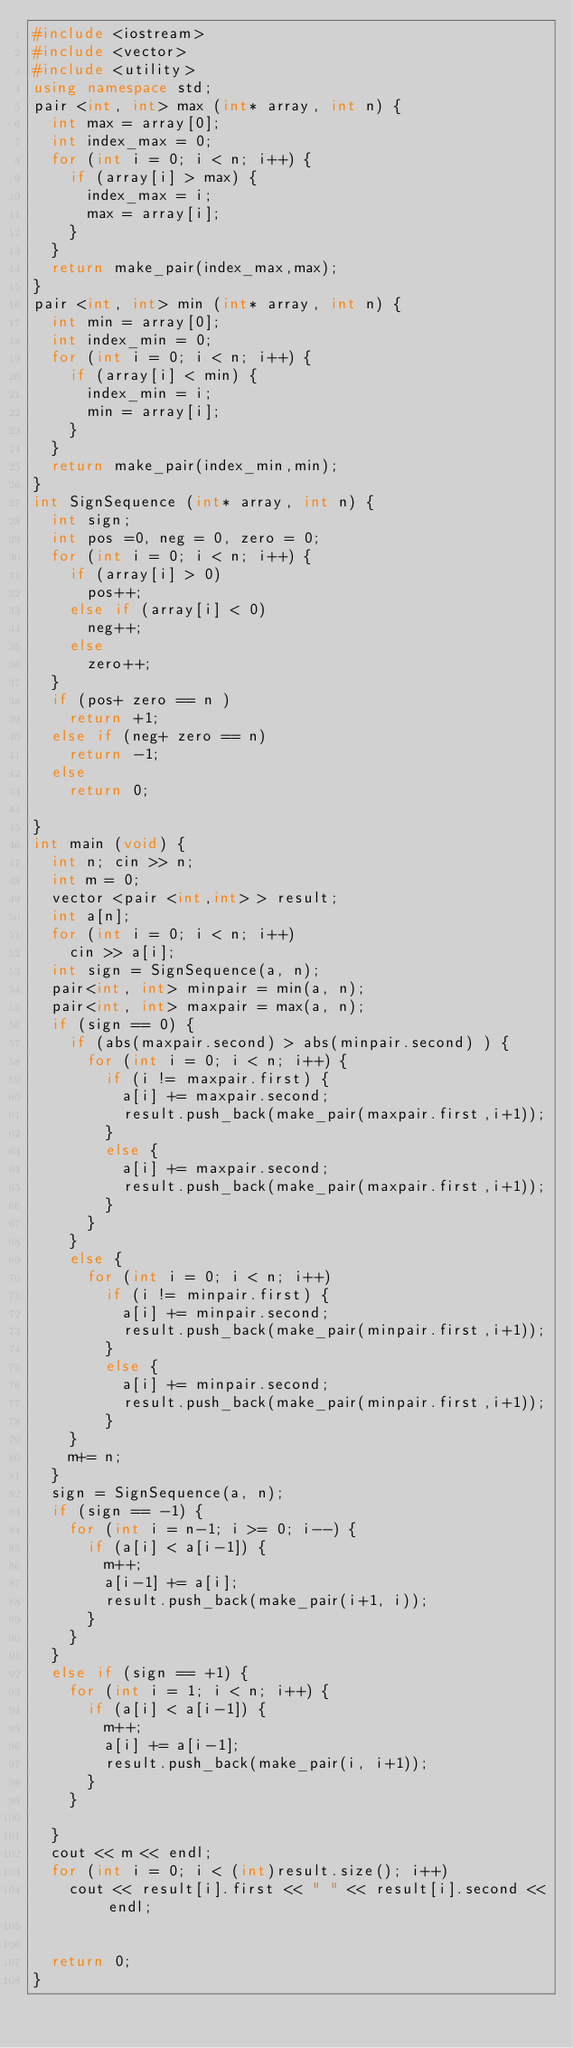Convert code to text. <code><loc_0><loc_0><loc_500><loc_500><_C++_>#include <iostream>
#include <vector>
#include <utility>
using namespace std;
pair <int, int> max (int* array, int n) {
	int max = array[0];
	int index_max = 0;
	for (int i = 0; i < n; i++) {
		if (array[i] > max) {
			index_max = i;
			max = array[i];
		}
	}
	return make_pair(index_max,max);
}
pair <int, int> min (int* array, int n) {
	int min = array[0];
	int index_min = 0;
	for (int i = 0; i < n; i++) {
		if (array[i] < min) {
			index_min = i;
			min = array[i];
		}
	}
	return make_pair(index_min,min);
}
int SignSequence (int* array, int n) {
	int sign;
	int pos =0, neg = 0, zero = 0;
	for (int i = 0; i < n; i++) {
		if (array[i] > 0)
			pos++;
		else if (array[i] < 0)
			neg++;
		else
			zero++;
	}
	if (pos+ zero == n )
		return +1;
	else if (neg+ zero == n)
		return -1;
	else
		return 0;

}
int main (void) {
	int n; cin >> n;
	int m = 0;
	vector <pair <int,int> > result;
	int a[n];
	for (int i = 0; i < n; i++)
		cin >> a[i];
	int sign = SignSequence(a, n);
	pair<int, int> minpair = min(a, n);
	pair<int, int> maxpair = max(a, n);
	if (sign == 0) {
		if (abs(maxpair.second) > abs(minpair.second) ) {
			for (int i = 0; i < n; i++) {
				if (i != maxpair.first) {
					a[i] += maxpair.second;
					result.push_back(make_pair(maxpair.first,i+1));
				}
				else {
					a[i] += maxpair.second;
					result.push_back(make_pair(maxpair.first,i+1));
				}
			}
		}
		else {
			for (int i = 0; i < n; i++)
				if (i != minpair.first) {
					a[i] += minpair.second;
					result.push_back(make_pair(minpair.first,i+1));
				}
				else {
					a[i] += minpair.second;
					result.push_back(make_pair(minpair.first,i+1));
				}
		}
		m+= n;
	}
	sign = SignSequence(a, n);
	if (sign == -1) {
		for (int i = n-1; i >= 0; i--) {
			if (a[i] < a[i-1]) {
				m++;
				a[i-1] += a[i];
				result.push_back(make_pair(i+1, i));
			}
		}
	}
	else if (sign == +1) {
		for (int i = 1; i < n; i++) {
			if (a[i] < a[i-1]) {
				m++;
				a[i] += a[i-1];
				result.push_back(make_pair(i, i+1));
			}
		}

	}
	cout << m << endl;
	for (int i = 0; i < (int)result.size(); i++)
		cout << result[i].first << " " << result[i].second << endl;


	return 0;
}</code> 